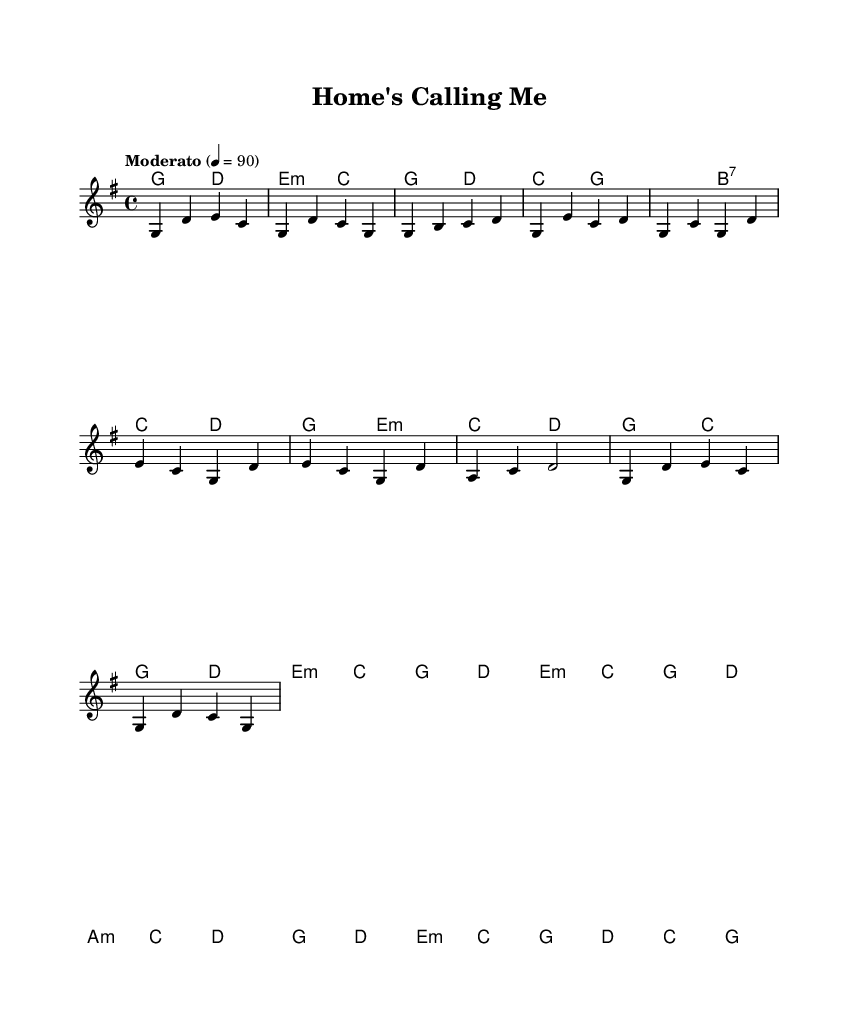What is the key signature of this music? The key signature indicated in the music is G major, which contains one sharp (F#). You can identify it by the key signature section located at the beginning of the staff in the sheet music.
Answer: G major What is the time signature of this piece? The time signature shown in the music is 4/4, which means there are four beats in each measure and the quarter note gets one beat. This can be determined by looking at the time signature notation placed at the beginning of the score.
Answer: 4/4 What is the tempo marking for this song? The tempo marking given in the sheet music is "Moderato," set at a speed of 90 beats per minute. This is visible in the tempo indication at the beginning of the piece.
Answer: Moderato, 90 What section follows the Chorus? The next section after the Chorus in this piece is the Bridge, which is a common structure in country music that provides contrast to the rest of the song. This can be inferred from the structure outlined in the sheet music.
Answer: Bridge How many measures are in the outro? The outro contains two measures, which can be counted by looking at the melody and harmonies notated at the end of the score. Each measure is delineated by vertical bar lines.
Answer: Two measures What chords are used in the verse? The chords specified for the verse are G, B7, C, D, G, and E minor. These chords can be identified by referencing the chord names written above the corresponding melody notes in the verse section of the score.
Answer: G, B7, C, D, G, E minor 